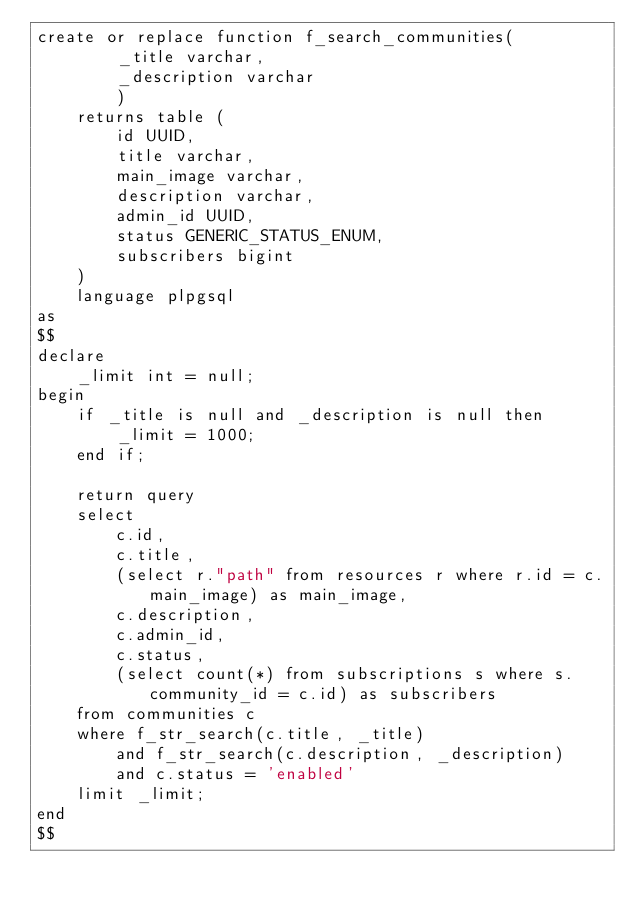<code> <loc_0><loc_0><loc_500><loc_500><_SQL_>create or replace function f_search_communities(
		_title varchar, 
		_description varchar
		)
	returns table (
		id UUID,
		title varchar,
		main_image varchar,
		description varchar,
		admin_id UUID,
		status GENERIC_STATUS_ENUM,
		subscribers bigint
	)
	language plpgsql
as
$$
declare
	_limit int = null;
begin
	if _title is null and _description is null then
		_limit = 1000;
	end if;
	
	return query
	select 
		c.id,
		c.title,
		(select r."path" from resources r where r.id = c.main_image) as main_image,
		c.description,
		c.admin_id,
		c.status,
		(select count(*) from subscriptions s where s.community_id = c.id) as subscribers
	from communities c
	where f_str_search(c.title, _title)
		and f_str_search(c.description, _description)
		and c.status = 'enabled'
	limit _limit;
end
$$
</code> 